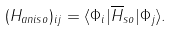<formula> <loc_0><loc_0><loc_500><loc_500>( H _ { a n i s o } ) _ { i j } = \langle \Phi _ { i } | \overline { H } _ { s o } | \Phi _ { j } \rangle .</formula> 